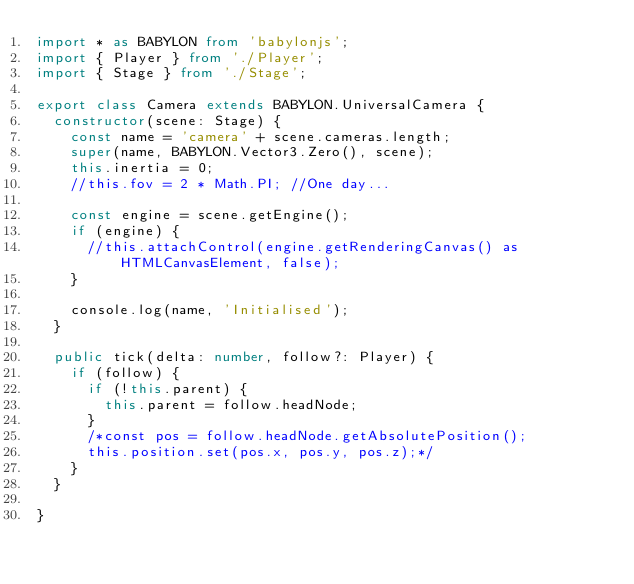<code> <loc_0><loc_0><loc_500><loc_500><_TypeScript_>import * as BABYLON from 'babylonjs';
import { Player } from './Player';
import { Stage } from './Stage';

export class Camera extends BABYLON.UniversalCamera {
  constructor(scene: Stage) {
    const name = 'camera' + scene.cameras.length;
    super(name, BABYLON.Vector3.Zero(), scene);
    this.inertia = 0;
    //this.fov = 2 * Math.PI; //One day...

    const engine = scene.getEngine();
    if (engine) {
      //this.attachControl(engine.getRenderingCanvas() as HTMLCanvasElement, false);
    }

    console.log(name, 'Initialised');
  }

  public tick(delta: number, follow?: Player) { 
    if (follow) {
      if (!this.parent) {
        this.parent = follow.headNode;
      }
      /*const pos = follow.headNode.getAbsolutePosition();
      this.position.set(pos.x, pos.y, pos.z);*/
    }
  }

}
</code> 